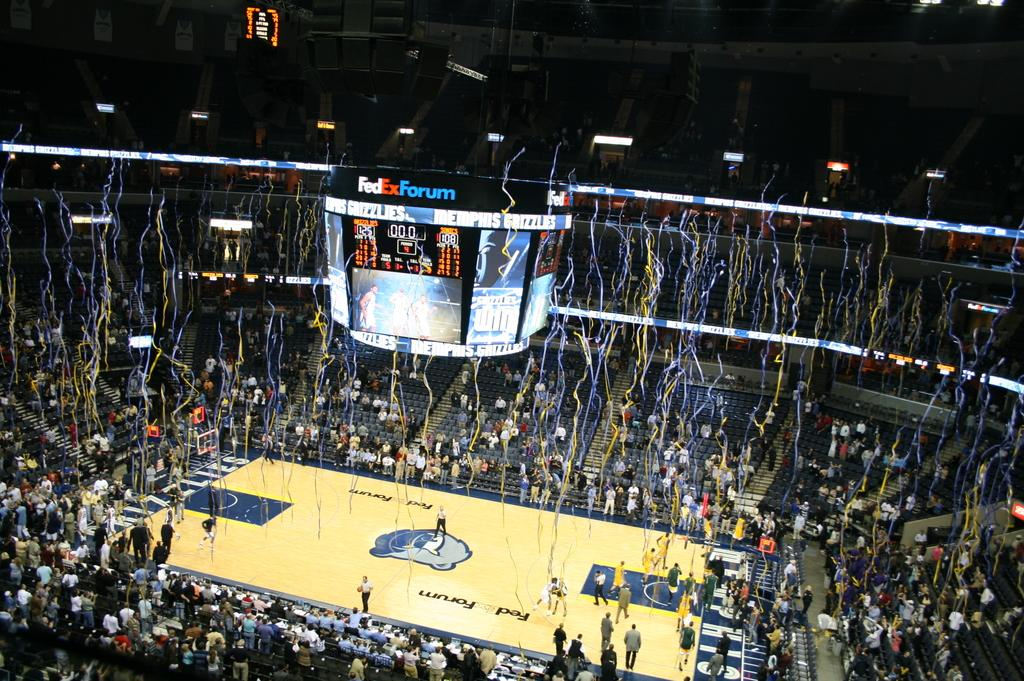<image>
Give a short and clear explanation of the subsequent image. Victory streamers are falling in a basketball arena where a team won with 125 points. 